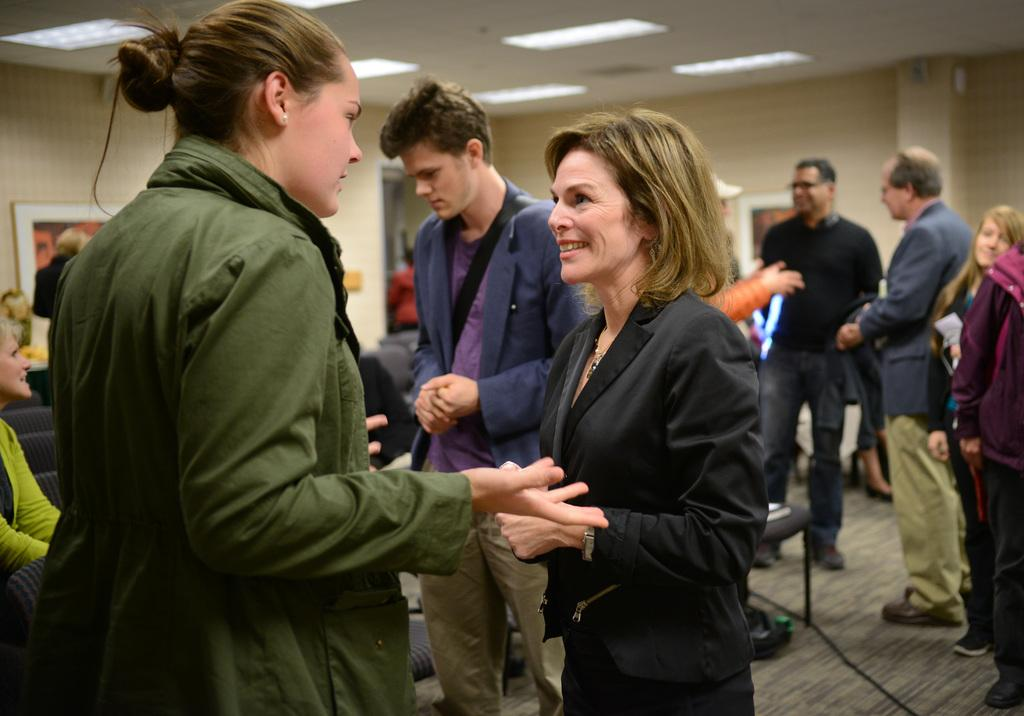How many people are visible in the image? There are two persons standing in the image. What can be seen in the background of the image? There is a group of people standing in the background of the image, as well as chairs, frames attached to the wall, and lights. What type of books are being passed around in the image? There are no books present in the image. Can you read the letters on the note being held by one of the persons in the image? There is no note present in the image. 